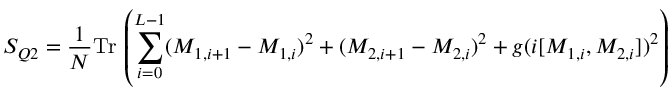Convert formula to latex. <formula><loc_0><loc_0><loc_500><loc_500>S _ { Q 2 } = \frac { 1 } { N } T r \, \left ( \sum _ { i = 0 } ^ { L - 1 } ( M _ { 1 , i + 1 } - M _ { 1 , i } ) ^ { 2 } + ( M _ { 2 , i + 1 } - M _ { 2 , i } ) ^ { 2 } + g ( i [ M _ { 1 , i } , M _ { 2 , i } ] ) ^ { 2 } \right )</formula> 